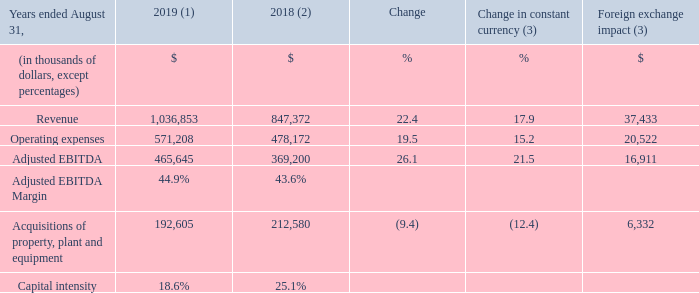OPERATING AND FINANCIAL RESULTS
(1) Fiscal 2019 average foreign exchange rate used for translation was 1.3255 USD/CDN.
(2) Fiscal 2018 was restated to comply with IFRS 15 and to reflect a change in accounting policy. For further details, please consult the "Accounting policies" section.
(3) Fiscal 2019 actuals are translated at the average foreign exchange rate of fiscal 2018 which was 1.2773 USD/CDN.
REVENUE Fiscal 2019 revenue increased by 22.4% (17.9% in constant currency). In local currency, revenue amounted to US$782.3 million compared to US$662.3 million for fiscal 2018. The increase resulted mainly from: • the impact of the MetroCast acquisition completed on January 4, 2018 which was included in revenue for only an eight-month period in the prior year; • rate increases; • continued growth in Internet service customers; and • the FiberLight acquisition completed in the first quarter of fiscal 2019; partly offset by • a decrease in video service customers. Excluding the MetroCast and FiberLight acquisitions, revenue in constant currency increased by 5.2% for fiscal 2019.
OPERATING EXPENSES Fiscal 2019 operating expenses increased by 19.5% (15.2% in constant currency) mainly as a result of: • the impact of the MetroCast acquisition which was included in operating expenses for only an eight-month period in the prior year; • programming rate increases; • the FiberLight acquisition completed in the first quarter of fiscal 2019; • higher compensation expenses due to higher headcount to support growth; and • higher marketing initiatives to drive primary service units growth; partly offset by • the prior year's non-recurring costs of $3.1 million (US$2.5 million) related to hurricane Irma.
ADJUSTED EBITDA Fiscal 2019 adjusted EBITDA increased by 26.1% (21.5% in constant currency). In local currency, adjusted EBITDA amounted to US$351.3 million compared to US$288.4 million for fiscal 2018. The increase was mainly due to the impact of the MetroCast and FiberLight acquisitions combined with strong organic growth. Excluding the MetroCast and FiberLight acquisitions and the prior year's non-recurring costs of $3.1 million ($US2.5 million) related to hurricane Irma, adjusted EBITDA in constant currency increased by 5.7% for fiscal 2019.
CAPITAL INTENSITY AND ACQUISITIONS OF PROPERTY, PLANT AND EQUIPMENT Fiscal 2019 acquisitions of property, plant and equipment decreased by 9.4% (12.4% in constant currency) mainly due to: • the acquisition of several dark fibres throughout south Florida from FiberLight, LLC for a consideration of $21.2 million (US$16.8 million) during the second quarter of fiscal 2018; partly offset by • additional capital expenditures related to the impact of the MetroCast acquisition; and • additional capital expenditures related to the expansion in Florida. Fiscal 2019 capital intensity reached 18.6% compared to 25.1% for fiscal 2018 mainly as a result of lower capital expenditures combined with revenue growth.
What was the average exchange rate in 2019? 1.3255 usd/cdn. What was the average exchange rate in 2018? 1.2773 usd/cdn. What was the increase in the operating expenses in 2019? 19.5%. What was the increase / (decrease) in the revenue from 2018 to 2019?
Answer scale should be: thousand. 1,036,853 - 847,372
Answer: 189481. What was the average operating expenses between 2018 and 2019?
Answer scale should be: thousand. (571,208 + 478,172) / 2
Answer: 524690. What was the increase / (decrease) in the Adjusted EBITDA from 2018 to 2019?
Answer scale should be: thousand. 465,645 - 369,200
Answer: 96445. 